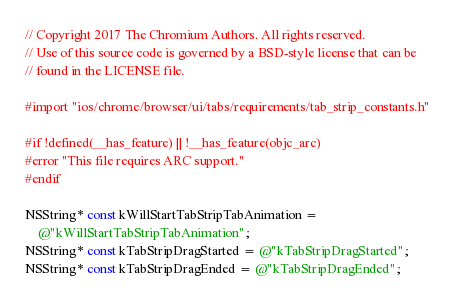<code> <loc_0><loc_0><loc_500><loc_500><_ObjectiveC_>// Copyright 2017 The Chromium Authors. All rights reserved.
// Use of this source code is governed by a BSD-style license that can be
// found in the LICENSE file.

#import "ios/chrome/browser/ui/tabs/requirements/tab_strip_constants.h"

#if !defined(__has_feature) || !__has_feature(objc_arc)
#error "This file requires ARC support."
#endif

NSString* const kWillStartTabStripTabAnimation =
    @"kWillStartTabStripTabAnimation";
NSString* const kTabStripDragStarted = @"kTabStripDragStarted";
NSString* const kTabStripDragEnded = @"kTabStripDragEnded";
</code> 